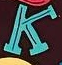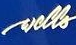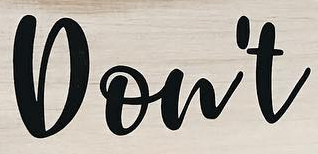Transcribe the words shown in these images in order, separated by a semicolon. K; wells; Don't 